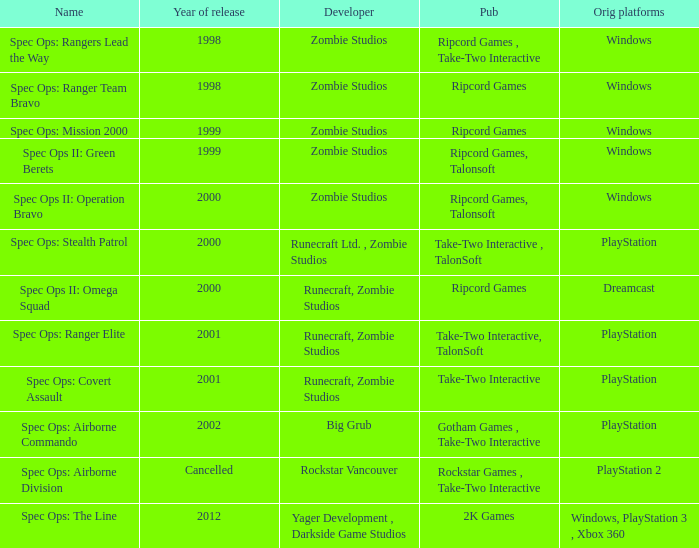Which publisher has release year of 2000 and an original dreamcast platform? Ripcord Games. Help me parse the entirety of this table. {'header': ['Name', 'Year of release', 'Developer', 'Pub', 'Orig platforms'], 'rows': [['Spec Ops: Rangers Lead the Way', '1998', 'Zombie Studios', 'Ripcord Games , Take-Two Interactive', 'Windows'], ['Spec Ops: Ranger Team Bravo', '1998', 'Zombie Studios', 'Ripcord Games', 'Windows'], ['Spec Ops: Mission 2000', '1999', 'Zombie Studios', 'Ripcord Games', 'Windows'], ['Spec Ops II: Green Berets', '1999', 'Zombie Studios', 'Ripcord Games, Talonsoft', 'Windows'], ['Spec Ops II: Operation Bravo', '2000', 'Zombie Studios', 'Ripcord Games, Talonsoft', 'Windows'], ['Spec Ops: Stealth Patrol', '2000', 'Runecraft Ltd. , Zombie Studios', 'Take-Two Interactive , TalonSoft', 'PlayStation'], ['Spec Ops II: Omega Squad', '2000', 'Runecraft, Zombie Studios', 'Ripcord Games', 'Dreamcast'], ['Spec Ops: Ranger Elite', '2001', 'Runecraft, Zombie Studios', 'Take-Two Interactive, TalonSoft', 'PlayStation'], ['Spec Ops: Covert Assault', '2001', 'Runecraft, Zombie Studios', 'Take-Two Interactive', 'PlayStation'], ['Spec Ops: Airborne Commando', '2002', 'Big Grub', 'Gotham Games , Take-Two Interactive', 'PlayStation'], ['Spec Ops: Airborne Division', 'Cancelled', 'Rockstar Vancouver', 'Rockstar Games , Take-Two Interactive', 'PlayStation 2'], ['Spec Ops: The Line', '2012', 'Yager Development , Darkside Game Studios', '2K Games', 'Windows, PlayStation 3 , Xbox 360']]} 